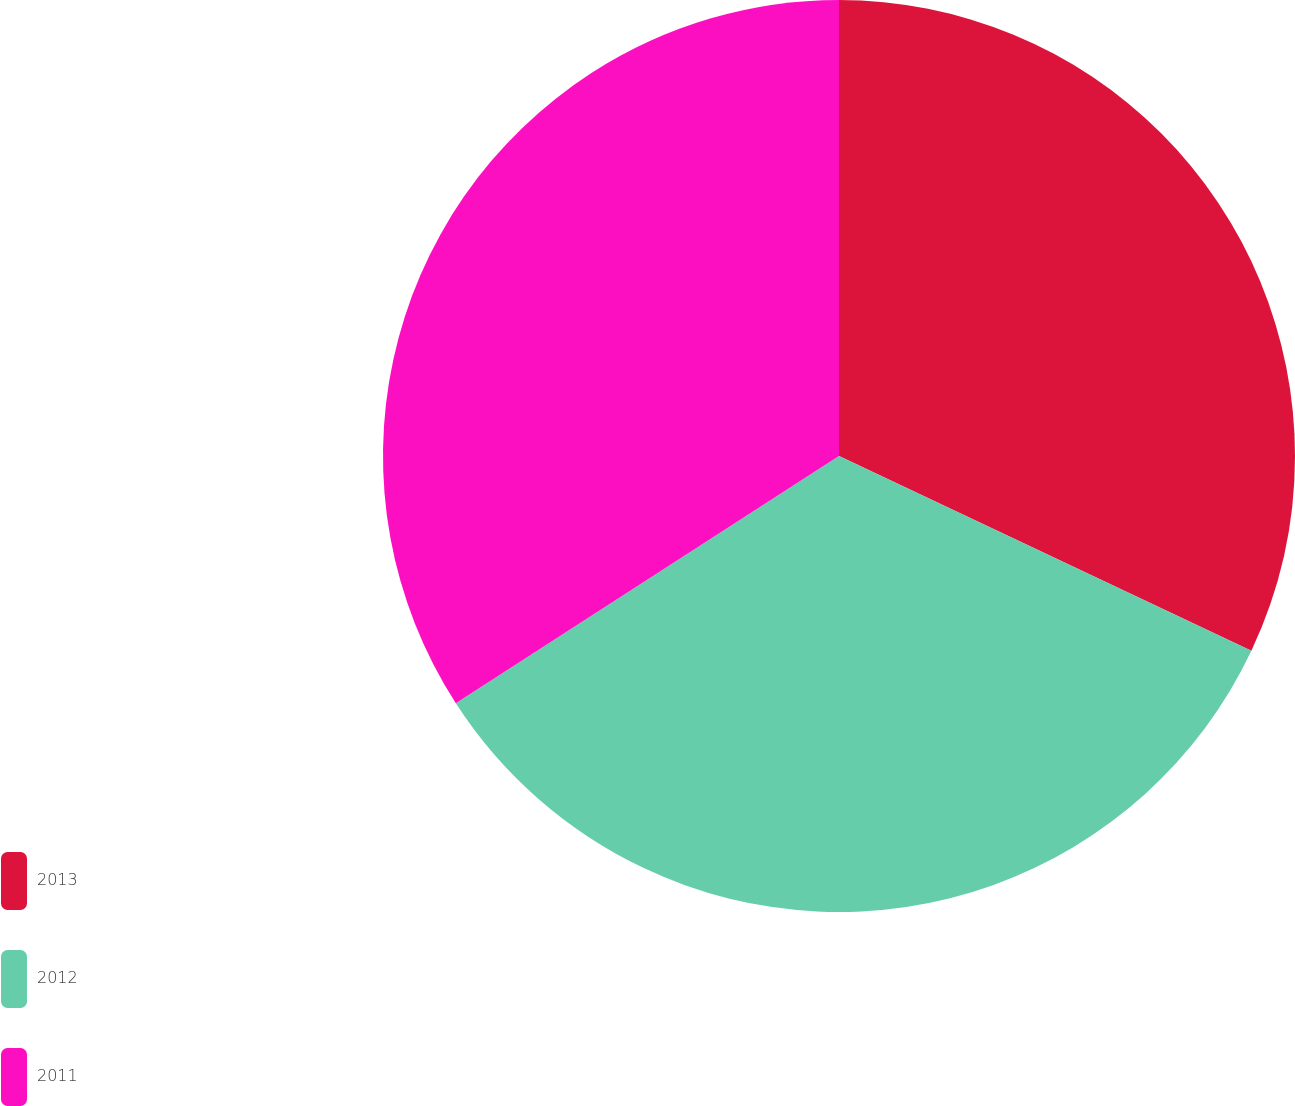<chart> <loc_0><loc_0><loc_500><loc_500><pie_chart><fcel>2013<fcel>2012<fcel>2011<nl><fcel>32.02%<fcel>33.86%<fcel>34.12%<nl></chart> 